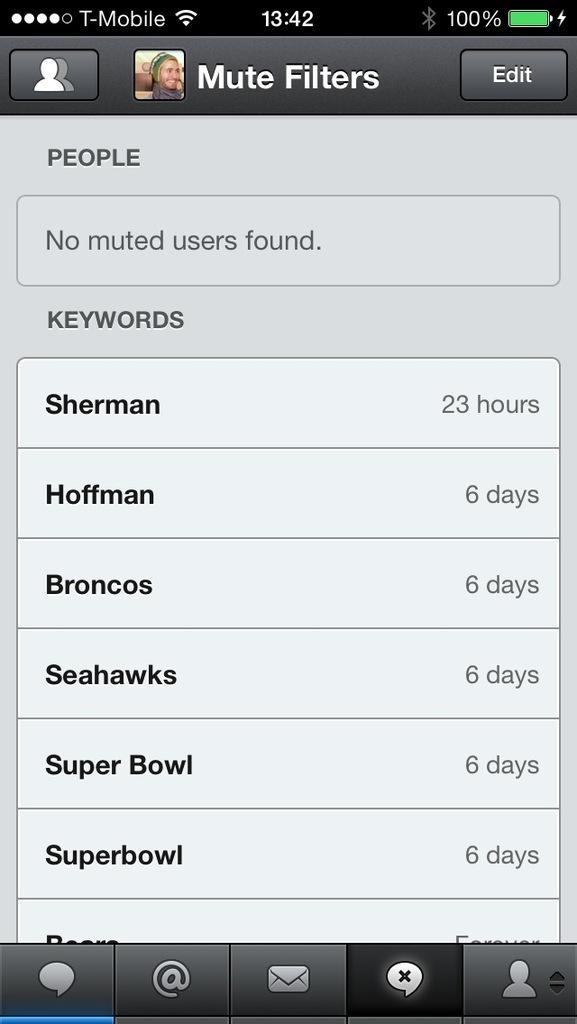<image>
Summarize the visual content of the image. Iphone with filters and football players and teams 